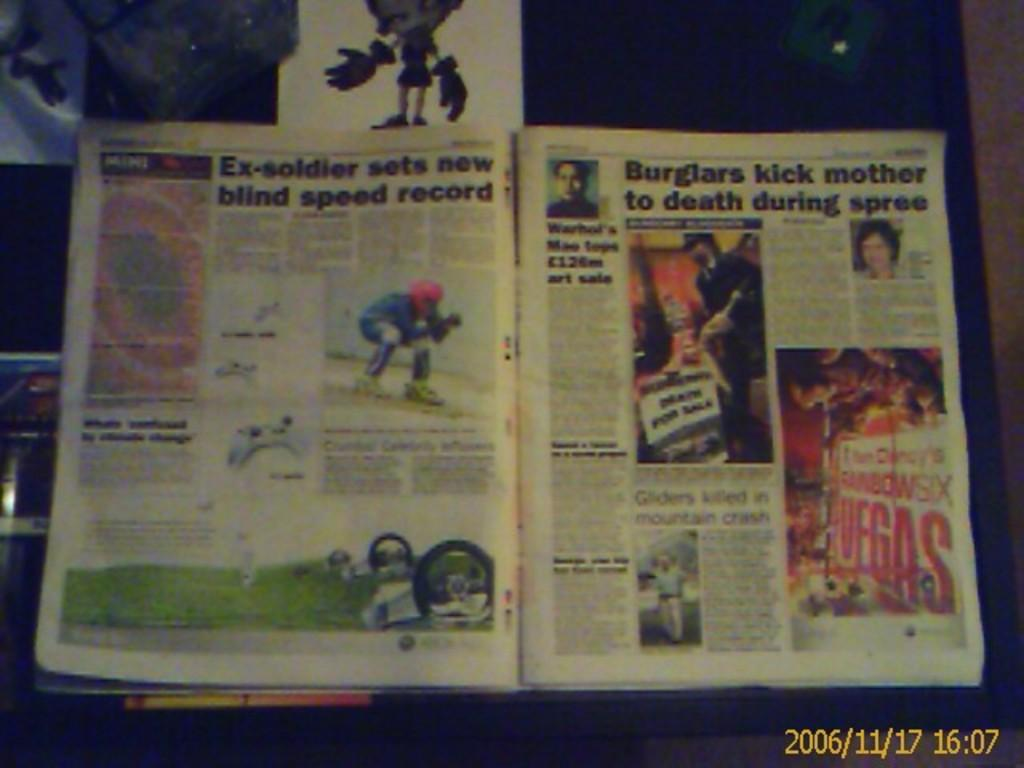<image>
Relay a brief, clear account of the picture shown. A magazine is open to a page about an ex soldier setting a new blind speed record. 